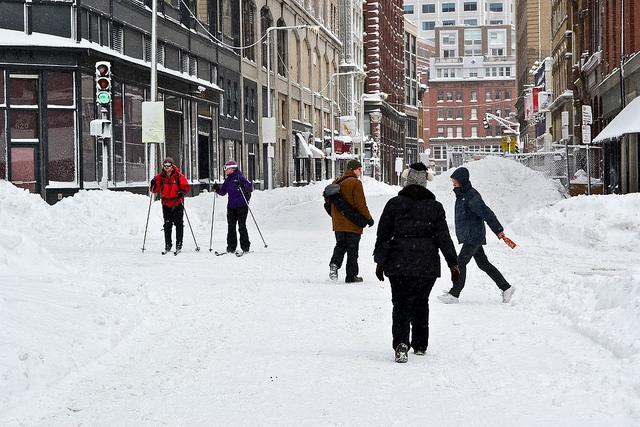What is the scene?
Be succinct. Winter. Was this photo taken in 2015?
Concise answer only. Yes. Was this photo taken recently"?
Keep it brief. Yes. Are they skiing in the city?
Write a very short answer. Yes. Have the walkways been shoveled?
Keep it brief. No. What color is the traffic light?
Be succinct. Green. What type of resort is this?
Short answer required. Ski. 